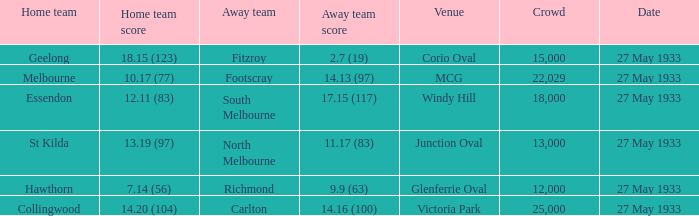In the match where the home team scored 14.20 (104), how many attendees were in the crowd? 25000.0. 